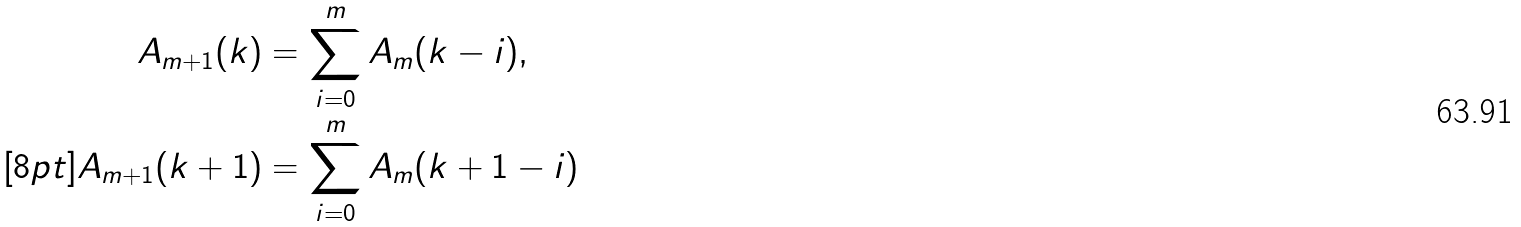<formula> <loc_0><loc_0><loc_500><loc_500>A _ { m + 1 } ( k ) & = \sum _ { i = 0 } ^ { m } A _ { m } ( k - i ) , \\ [ 8 p t ] A _ { m + 1 } ( k + 1 ) & = \sum _ { i = 0 } ^ { m } A _ { m } ( k + 1 - i )</formula> 